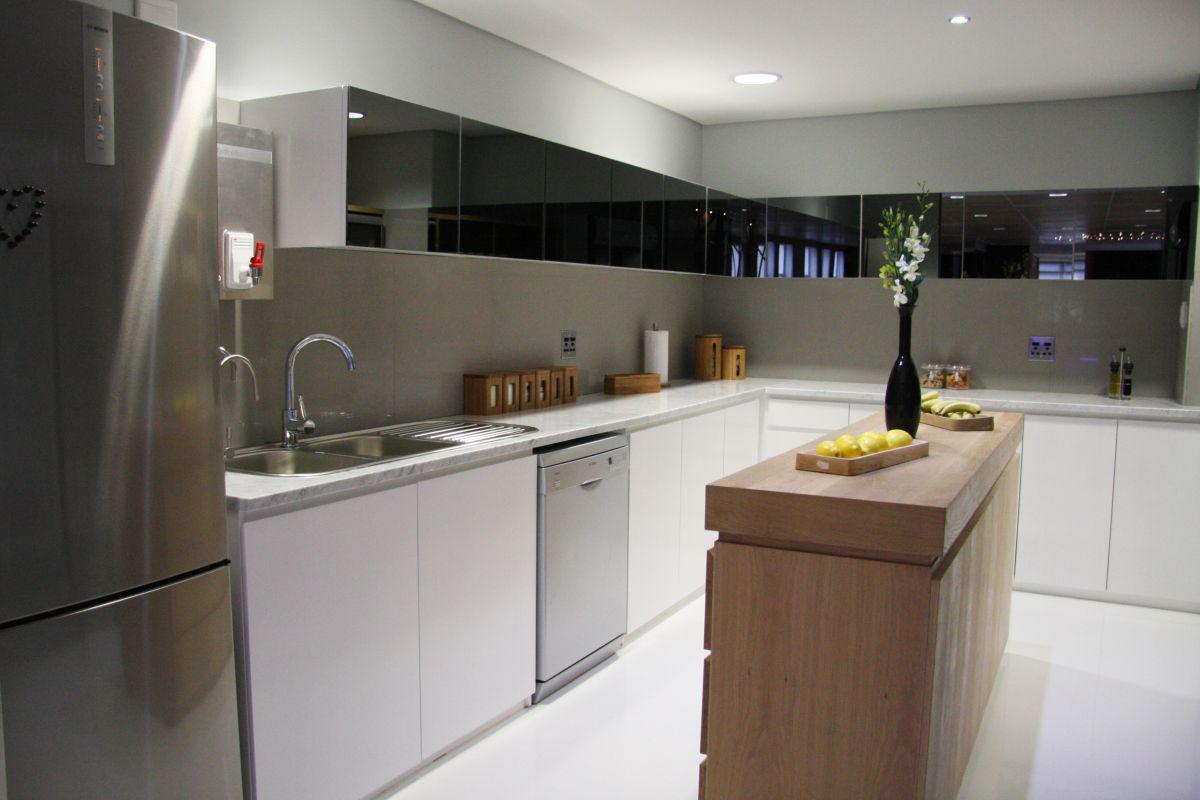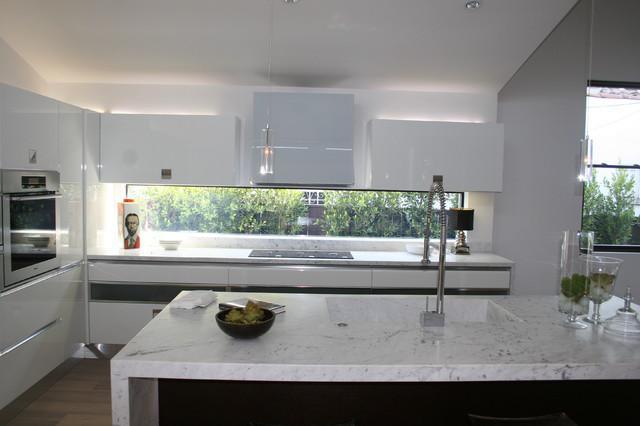The first image is the image on the left, the second image is the image on the right. For the images displayed, is the sentence "One kitchen has something decorative above and behind the sink, instead of a window to the outdoors." factually correct? Answer yes or no. No. The first image is the image on the left, the second image is the image on the right. Considering the images on both sides, is "A vase sits to the left of a sink with a window behind it." valid? Answer yes or no. No. 